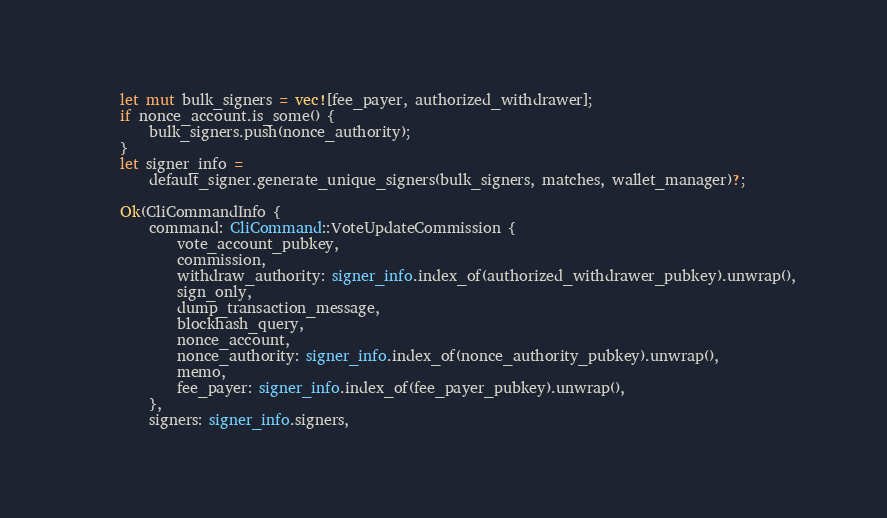<code> <loc_0><loc_0><loc_500><loc_500><_Rust_>
    let mut bulk_signers = vec![fee_payer, authorized_withdrawer];
    if nonce_account.is_some() {
        bulk_signers.push(nonce_authority);
    }
    let signer_info =
        default_signer.generate_unique_signers(bulk_signers, matches, wallet_manager)?;

    Ok(CliCommandInfo {
        command: CliCommand::VoteUpdateCommission {
            vote_account_pubkey,
            commission,
            withdraw_authority: signer_info.index_of(authorized_withdrawer_pubkey).unwrap(),
            sign_only,
            dump_transaction_message,
            blockhash_query,
            nonce_account,
            nonce_authority: signer_info.index_of(nonce_authority_pubkey).unwrap(),
            memo,
            fee_payer: signer_info.index_of(fee_payer_pubkey).unwrap(),
        },
        signers: signer_info.signers,</code> 